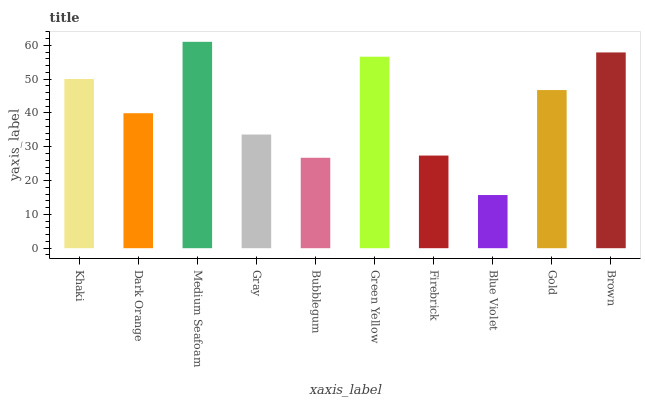Is Dark Orange the minimum?
Answer yes or no. No. Is Dark Orange the maximum?
Answer yes or no. No. Is Khaki greater than Dark Orange?
Answer yes or no. Yes. Is Dark Orange less than Khaki?
Answer yes or no. Yes. Is Dark Orange greater than Khaki?
Answer yes or no. No. Is Khaki less than Dark Orange?
Answer yes or no. No. Is Gold the high median?
Answer yes or no. Yes. Is Dark Orange the low median?
Answer yes or no. Yes. Is Gray the high median?
Answer yes or no. No. Is Khaki the low median?
Answer yes or no. No. 